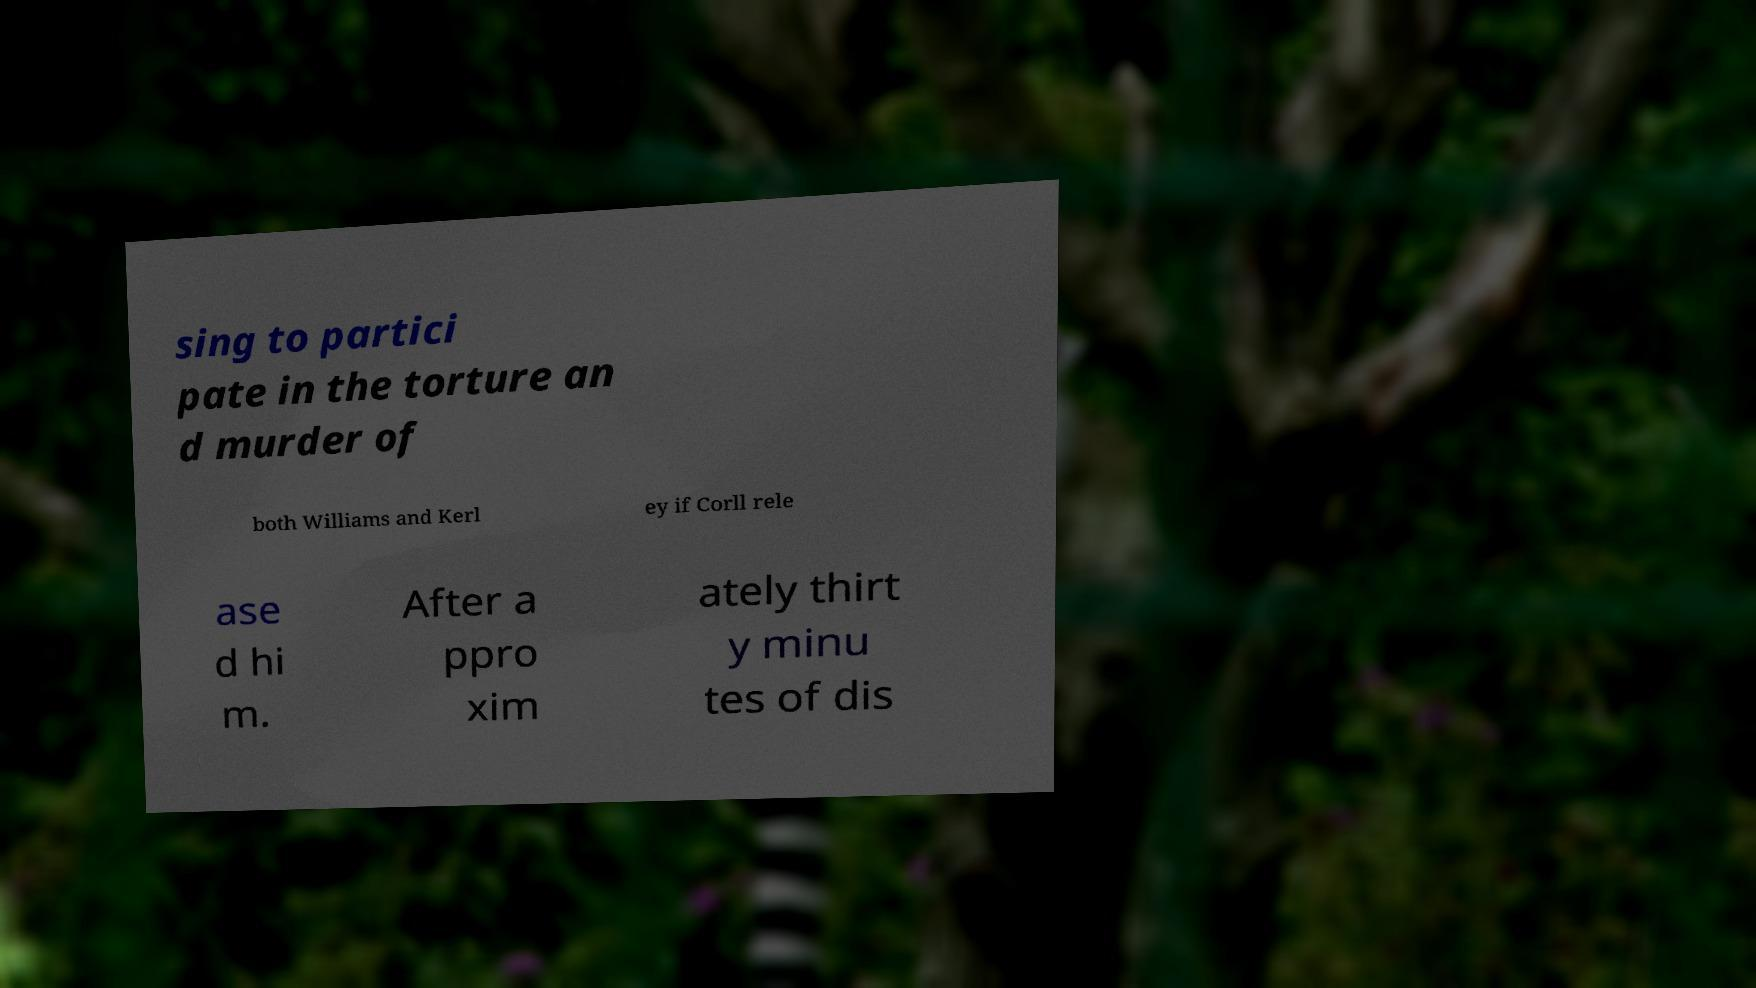What messages or text are displayed in this image? I need them in a readable, typed format. sing to partici pate in the torture an d murder of both Williams and Kerl ey if Corll rele ase d hi m. After a ppro xim ately thirt y minu tes of dis 